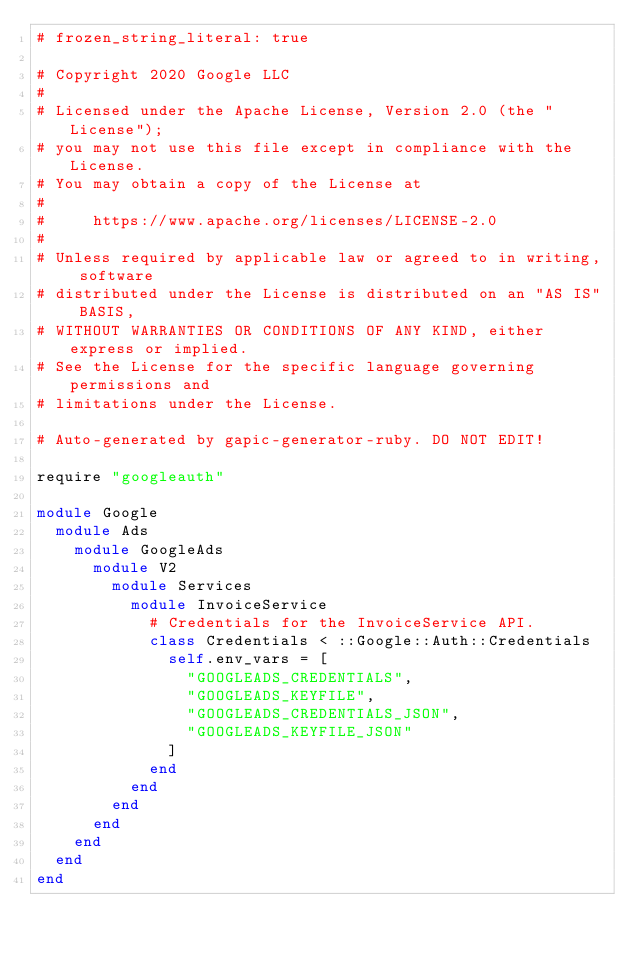<code> <loc_0><loc_0><loc_500><loc_500><_Ruby_># frozen_string_literal: true

# Copyright 2020 Google LLC
#
# Licensed under the Apache License, Version 2.0 (the "License");
# you may not use this file except in compliance with the License.
# You may obtain a copy of the License at
#
#     https://www.apache.org/licenses/LICENSE-2.0
#
# Unless required by applicable law or agreed to in writing, software
# distributed under the License is distributed on an "AS IS" BASIS,
# WITHOUT WARRANTIES OR CONDITIONS OF ANY KIND, either express or implied.
# See the License for the specific language governing permissions and
# limitations under the License.

# Auto-generated by gapic-generator-ruby. DO NOT EDIT!

require "googleauth"

module Google
  module Ads
    module GoogleAds
      module V2
        module Services
          module InvoiceService
            # Credentials for the InvoiceService API.
            class Credentials < ::Google::Auth::Credentials
              self.env_vars = [
                "GOOGLEADS_CREDENTIALS",
                "GOOGLEADS_KEYFILE",
                "GOOGLEADS_CREDENTIALS_JSON",
                "GOOGLEADS_KEYFILE_JSON"
              ]
            end
          end
        end
      end
    end
  end
end

</code> 